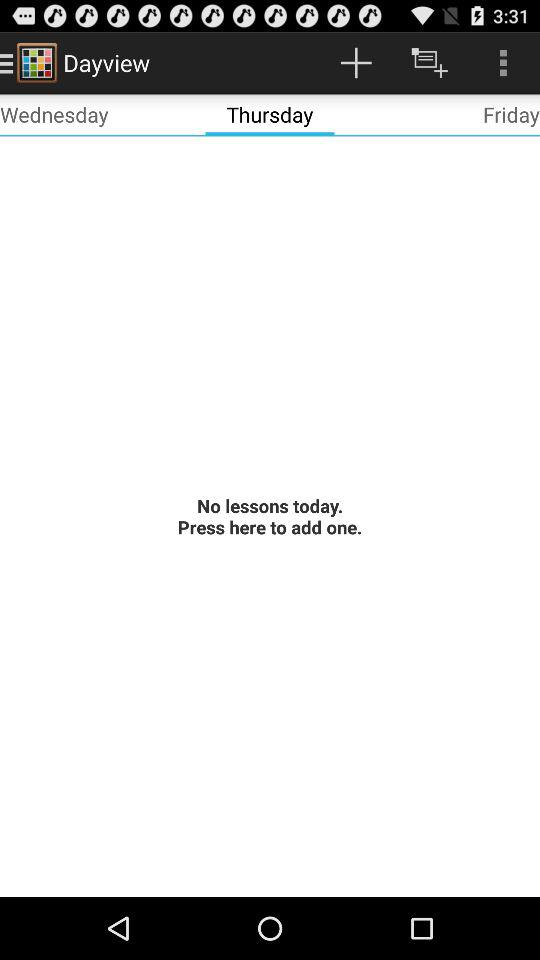Which tab is selected? The selected tab is "Thursday". 